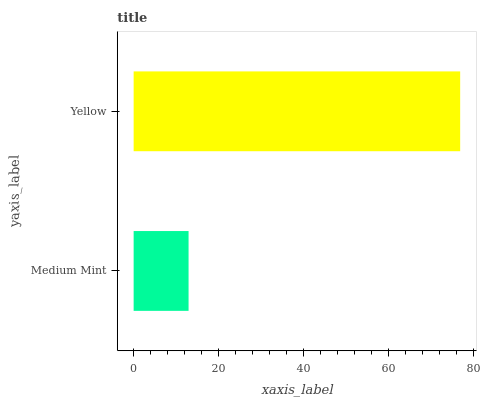Is Medium Mint the minimum?
Answer yes or no. Yes. Is Yellow the maximum?
Answer yes or no. Yes. Is Yellow the minimum?
Answer yes or no. No. Is Yellow greater than Medium Mint?
Answer yes or no. Yes. Is Medium Mint less than Yellow?
Answer yes or no. Yes. Is Medium Mint greater than Yellow?
Answer yes or no. No. Is Yellow less than Medium Mint?
Answer yes or no. No. Is Yellow the high median?
Answer yes or no. Yes. Is Medium Mint the low median?
Answer yes or no. Yes. Is Medium Mint the high median?
Answer yes or no. No. Is Yellow the low median?
Answer yes or no. No. 